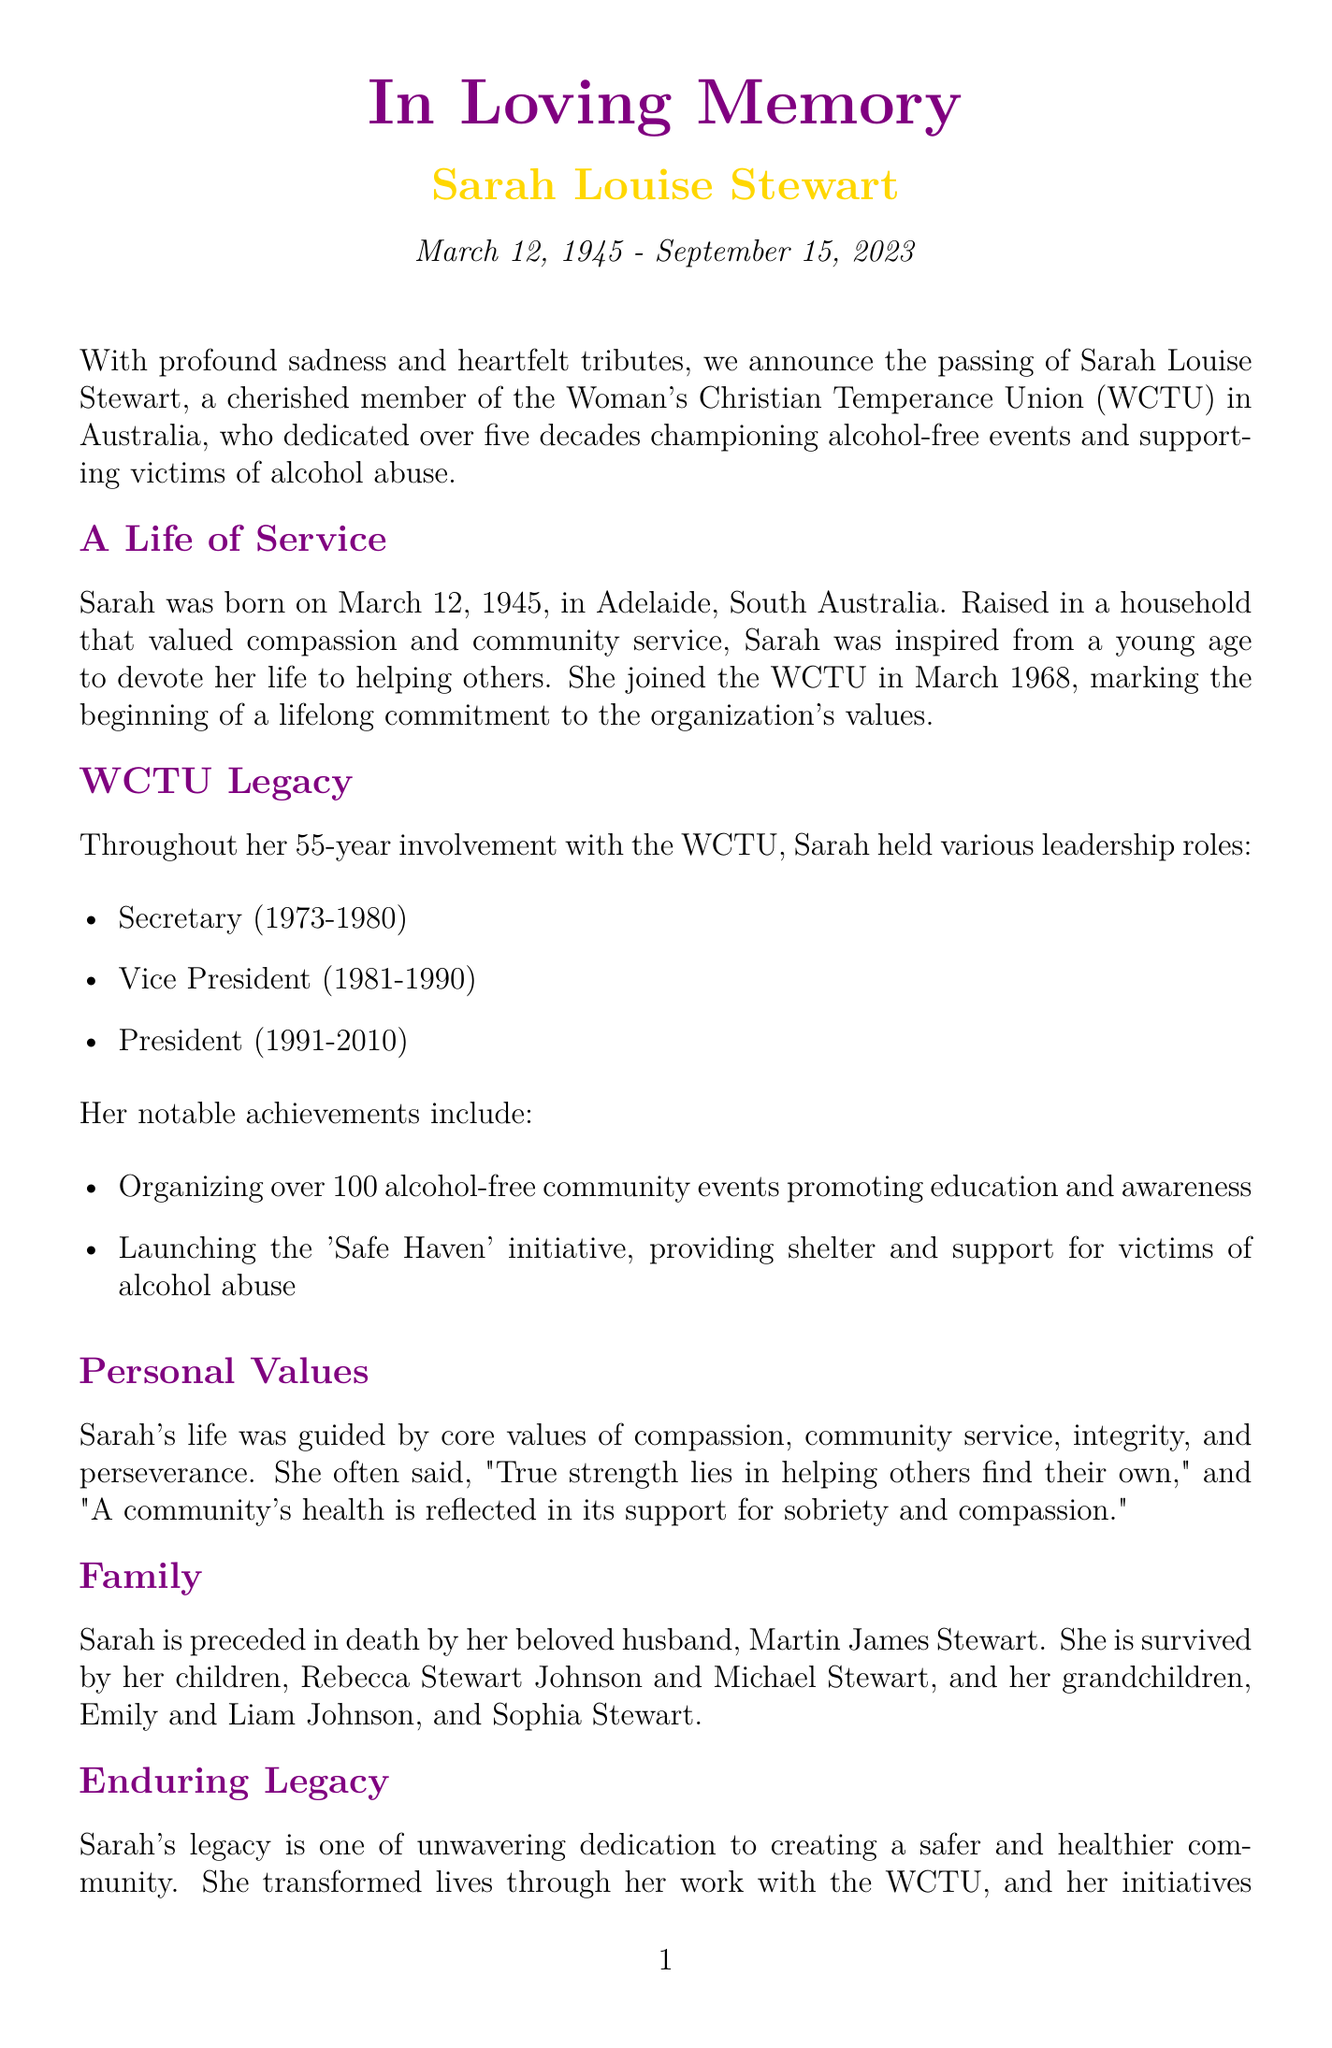What was Sarah's birth date? The document states that Sarah was born on March 12, 1945.
Answer: March 12, 1945 What position did Sarah hold from 1991 to 2010? According to the document, she served as the President during that time.
Answer: President How many years did Sarah serve in WCTU? The document indicates she was involved for 55 years.
Answer: 55 years What initiative did Sarah launch to support alcohol abuse victims? The document mentions the 'Safe Haven' initiative as her achievement for supporting victims.
Answer: Safe Haven What quote reflects Sarah's personal values? The document records her quote, "True strength lies in helping others find their own."
Answer: "True strength lies in helping others find their own." How many children did Sarah have? The document states she is survived by two children, Rebecca and Michael.
Answer: Two What was one of Sarah's notable achievements? The document outlines that she organized over 100 alcohol-free community events.
Answer: Organizing over 100 alcohol-free community events Who is mentioned as Sarah’s husband in the obituary? The document states that she was preceded in death by her husband, Martin James Stewart.
Answer: Martin James Stewart 